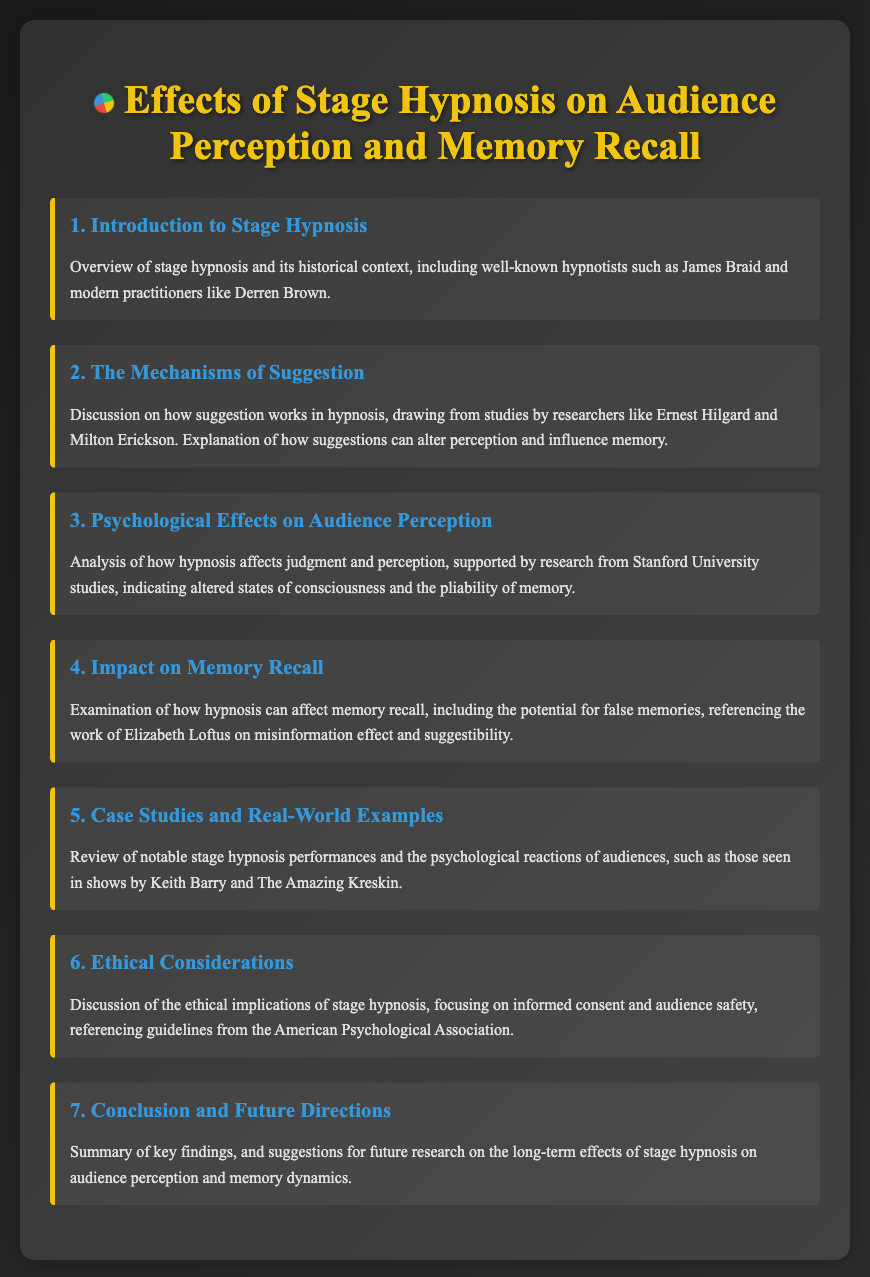What is the title of the document? The title is provided in the HTML document as "Effects of Stage Hypnosis on Audience Perception and Memory Recall".
Answer: Effects of Stage Hypnosis on Audience Perception and Memory Recall Who conducted significant studies mentioned in the document? The document references researchers such as Ernest Hilgard and Milton Erickson for their work on suggestion in hypnosis.
Answer: Ernest Hilgard and Milton Erickson What ethical guidelines are referenced in the document? The document mentions guidelines from the American Psychological Association regarding the ethical implications of stage hypnosis.
Answer: American Psychological Association How many main agenda items are listed in the document? The document outlines a total of seven main agenda items.
Answer: 7 What is one psychological effect discussed in the document? The document states that hypnosis can alter judgment and perception, supported by research from Stanford University studies.
Answer: Altered judgment and perception Which notable hypnotists are mentioned in the introduction? The introduction references historical hypnotists including James Braid and modern practitioners such as Derren Brown.
Answer: James Braid and Derren Brown What long-term effect is suggested for future research? The document suggests researching the long-term effects of stage hypnosis on audience perception and memory dynamics.
Answer: Long-term effects on audience perception and memory dynamics 